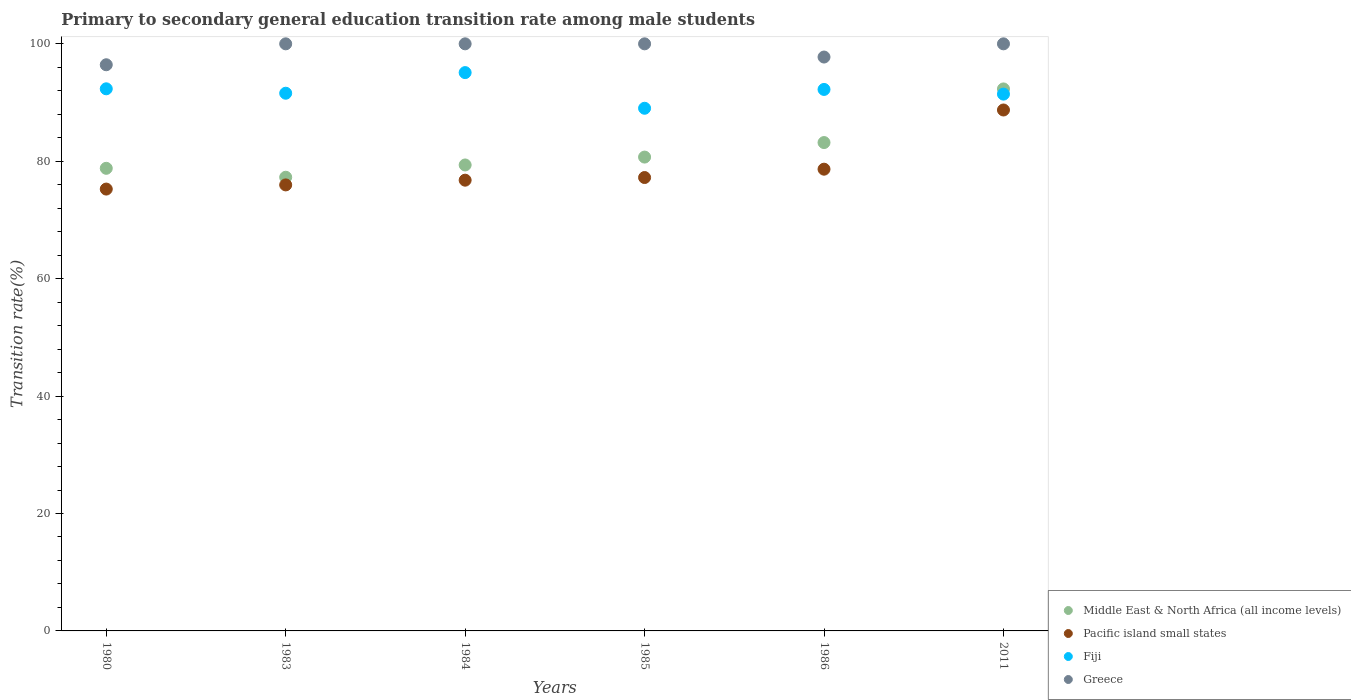How many different coloured dotlines are there?
Keep it short and to the point. 4. What is the transition rate in Greece in 1985?
Offer a very short reply. 100. Across all years, what is the maximum transition rate in Middle East & North Africa (all income levels)?
Offer a very short reply. 92.32. Across all years, what is the minimum transition rate in Greece?
Your response must be concise. 96.44. In which year was the transition rate in Middle East & North Africa (all income levels) maximum?
Ensure brevity in your answer.  2011. What is the total transition rate in Greece in the graph?
Offer a very short reply. 594.19. What is the difference between the transition rate in Pacific island small states in 1985 and that in 2011?
Keep it short and to the point. -11.5. What is the difference between the transition rate in Pacific island small states in 1986 and the transition rate in Fiji in 1980?
Ensure brevity in your answer.  -13.69. What is the average transition rate in Middle East & North Africa (all income levels) per year?
Provide a succinct answer. 81.94. In the year 1985, what is the difference between the transition rate in Pacific island small states and transition rate in Fiji?
Ensure brevity in your answer.  -11.8. In how many years, is the transition rate in Greece greater than 8 %?
Your answer should be compact. 6. What is the ratio of the transition rate in Fiji in 1980 to that in 1985?
Offer a terse response. 1.04. Is the transition rate in Middle East & North Africa (all income levels) in 1984 less than that in 1985?
Provide a succinct answer. Yes. Is the difference between the transition rate in Pacific island small states in 1986 and 2011 greater than the difference between the transition rate in Fiji in 1986 and 2011?
Provide a short and direct response. No. What is the difference between the highest and the second highest transition rate in Pacific island small states?
Your answer should be compact. 10.08. What is the difference between the highest and the lowest transition rate in Greece?
Your response must be concise. 3.56. Is it the case that in every year, the sum of the transition rate in Greece and transition rate in Fiji  is greater than the sum of transition rate in Middle East & North Africa (all income levels) and transition rate in Pacific island small states?
Make the answer very short. Yes. Does the transition rate in Pacific island small states monotonically increase over the years?
Your answer should be compact. Yes. How many dotlines are there?
Your answer should be compact. 4. What is the difference between two consecutive major ticks on the Y-axis?
Ensure brevity in your answer.  20. Does the graph contain any zero values?
Provide a succinct answer. No. Does the graph contain grids?
Offer a very short reply. No. Where does the legend appear in the graph?
Keep it short and to the point. Bottom right. How many legend labels are there?
Offer a very short reply. 4. How are the legend labels stacked?
Your answer should be very brief. Vertical. What is the title of the graph?
Give a very brief answer. Primary to secondary general education transition rate among male students. What is the label or title of the X-axis?
Offer a very short reply. Years. What is the label or title of the Y-axis?
Keep it short and to the point. Transition rate(%). What is the Transition rate(%) in Middle East & North Africa (all income levels) in 1980?
Offer a very short reply. 78.8. What is the Transition rate(%) of Pacific island small states in 1980?
Your answer should be compact. 75.26. What is the Transition rate(%) of Fiji in 1980?
Your answer should be compact. 92.34. What is the Transition rate(%) of Greece in 1980?
Your answer should be very brief. 96.44. What is the Transition rate(%) of Middle East & North Africa (all income levels) in 1983?
Offer a very short reply. 77.28. What is the Transition rate(%) in Pacific island small states in 1983?
Make the answer very short. 75.97. What is the Transition rate(%) of Fiji in 1983?
Your answer should be very brief. 91.59. What is the Transition rate(%) in Greece in 1983?
Give a very brief answer. 100. What is the Transition rate(%) in Middle East & North Africa (all income levels) in 1984?
Ensure brevity in your answer.  79.37. What is the Transition rate(%) in Pacific island small states in 1984?
Offer a very short reply. 76.78. What is the Transition rate(%) in Fiji in 1984?
Offer a very short reply. 95.1. What is the Transition rate(%) of Middle East & North Africa (all income levels) in 1985?
Offer a very short reply. 80.71. What is the Transition rate(%) of Pacific island small states in 1985?
Provide a short and direct response. 77.23. What is the Transition rate(%) of Fiji in 1985?
Make the answer very short. 89.03. What is the Transition rate(%) in Middle East & North Africa (all income levels) in 1986?
Keep it short and to the point. 83.18. What is the Transition rate(%) in Pacific island small states in 1986?
Your answer should be very brief. 78.65. What is the Transition rate(%) of Fiji in 1986?
Provide a short and direct response. 92.23. What is the Transition rate(%) of Greece in 1986?
Provide a succinct answer. 97.75. What is the Transition rate(%) of Middle East & North Africa (all income levels) in 2011?
Make the answer very short. 92.32. What is the Transition rate(%) of Pacific island small states in 2011?
Provide a short and direct response. 88.73. What is the Transition rate(%) of Fiji in 2011?
Provide a short and direct response. 91.44. What is the Transition rate(%) of Greece in 2011?
Your response must be concise. 100. Across all years, what is the maximum Transition rate(%) of Middle East & North Africa (all income levels)?
Provide a succinct answer. 92.32. Across all years, what is the maximum Transition rate(%) of Pacific island small states?
Offer a very short reply. 88.73. Across all years, what is the maximum Transition rate(%) in Fiji?
Provide a short and direct response. 95.1. Across all years, what is the maximum Transition rate(%) in Greece?
Your answer should be very brief. 100. Across all years, what is the minimum Transition rate(%) in Middle East & North Africa (all income levels)?
Offer a terse response. 77.28. Across all years, what is the minimum Transition rate(%) of Pacific island small states?
Make the answer very short. 75.26. Across all years, what is the minimum Transition rate(%) in Fiji?
Give a very brief answer. 89.03. Across all years, what is the minimum Transition rate(%) in Greece?
Your response must be concise. 96.44. What is the total Transition rate(%) in Middle East & North Africa (all income levels) in the graph?
Your answer should be very brief. 491.66. What is the total Transition rate(%) in Pacific island small states in the graph?
Make the answer very short. 472.62. What is the total Transition rate(%) of Fiji in the graph?
Ensure brevity in your answer.  551.72. What is the total Transition rate(%) in Greece in the graph?
Your response must be concise. 594.19. What is the difference between the Transition rate(%) of Middle East & North Africa (all income levels) in 1980 and that in 1983?
Offer a very short reply. 1.52. What is the difference between the Transition rate(%) in Pacific island small states in 1980 and that in 1983?
Make the answer very short. -0.71. What is the difference between the Transition rate(%) in Fiji in 1980 and that in 1983?
Provide a succinct answer. 0.75. What is the difference between the Transition rate(%) in Greece in 1980 and that in 1983?
Keep it short and to the point. -3.56. What is the difference between the Transition rate(%) in Middle East & North Africa (all income levels) in 1980 and that in 1984?
Ensure brevity in your answer.  -0.57. What is the difference between the Transition rate(%) of Pacific island small states in 1980 and that in 1984?
Make the answer very short. -1.51. What is the difference between the Transition rate(%) of Fiji in 1980 and that in 1984?
Ensure brevity in your answer.  -2.76. What is the difference between the Transition rate(%) in Greece in 1980 and that in 1984?
Provide a short and direct response. -3.56. What is the difference between the Transition rate(%) in Middle East & North Africa (all income levels) in 1980 and that in 1985?
Provide a succinct answer. -1.91. What is the difference between the Transition rate(%) in Pacific island small states in 1980 and that in 1985?
Make the answer very short. -1.97. What is the difference between the Transition rate(%) in Fiji in 1980 and that in 1985?
Give a very brief answer. 3.31. What is the difference between the Transition rate(%) of Greece in 1980 and that in 1985?
Offer a very short reply. -3.56. What is the difference between the Transition rate(%) of Middle East & North Africa (all income levels) in 1980 and that in 1986?
Your response must be concise. -4.39. What is the difference between the Transition rate(%) of Pacific island small states in 1980 and that in 1986?
Your answer should be compact. -3.39. What is the difference between the Transition rate(%) in Fiji in 1980 and that in 1986?
Your answer should be compact. 0.11. What is the difference between the Transition rate(%) in Greece in 1980 and that in 1986?
Your answer should be very brief. -1.32. What is the difference between the Transition rate(%) in Middle East & North Africa (all income levels) in 1980 and that in 2011?
Offer a very short reply. -13.52. What is the difference between the Transition rate(%) in Pacific island small states in 1980 and that in 2011?
Provide a succinct answer. -13.47. What is the difference between the Transition rate(%) in Fiji in 1980 and that in 2011?
Your answer should be very brief. 0.9. What is the difference between the Transition rate(%) of Greece in 1980 and that in 2011?
Your answer should be compact. -3.56. What is the difference between the Transition rate(%) of Middle East & North Africa (all income levels) in 1983 and that in 1984?
Give a very brief answer. -2.09. What is the difference between the Transition rate(%) in Pacific island small states in 1983 and that in 1984?
Your answer should be compact. -0.81. What is the difference between the Transition rate(%) of Fiji in 1983 and that in 1984?
Ensure brevity in your answer.  -3.51. What is the difference between the Transition rate(%) in Middle East & North Africa (all income levels) in 1983 and that in 1985?
Provide a short and direct response. -3.43. What is the difference between the Transition rate(%) of Pacific island small states in 1983 and that in 1985?
Ensure brevity in your answer.  -1.26. What is the difference between the Transition rate(%) of Fiji in 1983 and that in 1985?
Offer a very short reply. 2.56. What is the difference between the Transition rate(%) of Greece in 1983 and that in 1985?
Your response must be concise. 0. What is the difference between the Transition rate(%) of Middle East & North Africa (all income levels) in 1983 and that in 1986?
Offer a very short reply. -5.91. What is the difference between the Transition rate(%) in Pacific island small states in 1983 and that in 1986?
Offer a very short reply. -2.68. What is the difference between the Transition rate(%) in Fiji in 1983 and that in 1986?
Make the answer very short. -0.65. What is the difference between the Transition rate(%) of Greece in 1983 and that in 1986?
Make the answer very short. 2.25. What is the difference between the Transition rate(%) in Middle East & North Africa (all income levels) in 1983 and that in 2011?
Offer a terse response. -15.04. What is the difference between the Transition rate(%) in Pacific island small states in 1983 and that in 2011?
Ensure brevity in your answer.  -12.76. What is the difference between the Transition rate(%) in Fiji in 1983 and that in 2011?
Offer a very short reply. 0.15. What is the difference between the Transition rate(%) of Middle East & North Africa (all income levels) in 1984 and that in 1985?
Keep it short and to the point. -1.34. What is the difference between the Transition rate(%) in Pacific island small states in 1984 and that in 1985?
Offer a very short reply. -0.45. What is the difference between the Transition rate(%) of Fiji in 1984 and that in 1985?
Your response must be concise. 6.07. What is the difference between the Transition rate(%) in Middle East & North Africa (all income levels) in 1984 and that in 1986?
Your answer should be very brief. -3.82. What is the difference between the Transition rate(%) in Pacific island small states in 1984 and that in 1986?
Give a very brief answer. -1.87. What is the difference between the Transition rate(%) of Fiji in 1984 and that in 1986?
Keep it short and to the point. 2.87. What is the difference between the Transition rate(%) in Greece in 1984 and that in 1986?
Give a very brief answer. 2.25. What is the difference between the Transition rate(%) of Middle East & North Africa (all income levels) in 1984 and that in 2011?
Provide a succinct answer. -12.95. What is the difference between the Transition rate(%) of Pacific island small states in 1984 and that in 2011?
Provide a succinct answer. -11.96. What is the difference between the Transition rate(%) in Fiji in 1984 and that in 2011?
Keep it short and to the point. 3.66. What is the difference between the Transition rate(%) of Greece in 1984 and that in 2011?
Provide a succinct answer. 0. What is the difference between the Transition rate(%) in Middle East & North Africa (all income levels) in 1985 and that in 1986?
Ensure brevity in your answer.  -2.47. What is the difference between the Transition rate(%) of Pacific island small states in 1985 and that in 1986?
Keep it short and to the point. -1.42. What is the difference between the Transition rate(%) of Fiji in 1985 and that in 1986?
Provide a short and direct response. -3.21. What is the difference between the Transition rate(%) in Greece in 1985 and that in 1986?
Give a very brief answer. 2.25. What is the difference between the Transition rate(%) of Middle East & North Africa (all income levels) in 1985 and that in 2011?
Your answer should be compact. -11.61. What is the difference between the Transition rate(%) of Pacific island small states in 1985 and that in 2011?
Offer a very short reply. -11.5. What is the difference between the Transition rate(%) of Fiji in 1985 and that in 2011?
Offer a terse response. -2.41. What is the difference between the Transition rate(%) in Middle East & North Africa (all income levels) in 1986 and that in 2011?
Keep it short and to the point. -9.14. What is the difference between the Transition rate(%) of Pacific island small states in 1986 and that in 2011?
Ensure brevity in your answer.  -10.08. What is the difference between the Transition rate(%) of Fiji in 1986 and that in 2011?
Your answer should be very brief. 0.8. What is the difference between the Transition rate(%) of Greece in 1986 and that in 2011?
Give a very brief answer. -2.25. What is the difference between the Transition rate(%) of Middle East & North Africa (all income levels) in 1980 and the Transition rate(%) of Pacific island small states in 1983?
Offer a very short reply. 2.83. What is the difference between the Transition rate(%) of Middle East & North Africa (all income levels) in 1980 and the Transition rate(%) of Fiji in 1983?
Offer a terse response. -12.79. What is the difference between the Transition rate(%) of Middle East & North Africa (all income levels) in 1980 and the Transition rate(%) of Greece in 1983?
Your answer should be very brief. -21.2. What is the difference between the Transition rate(%) in Pacific island small states in 1980 and the Transition rate(%) in Fiji in 1983?
Ensure brevity in your answer.  -16.33. What is the difference between the Transition rate(%) of Pacific island small states in 1980 and the Transition rate(%) of Greece in 1983?
Your answer should be compact. -24.74. What is the difference between the Transition rate(%) in Fiji in 1980 and the Transition rate(%) in Greece in 1983?
Keep it short and to the point. -7.66. What is the difference between the Transition rate(%) in Middle East & North Africa (all income levels) in 1980 and the Transition rate(%) in Pacific island small states in 1984?
Make the answer very short. 2.02. What is the difference between the Transition rate(%) of Middle East & North Africa (all income levels) in 1980 and the Transition rate(%) of Fiji in 1984?
Offer a very short reply. -16.3. What is the difference between the Transition rate(%) of Middle East & North Africa (all income levels) in 1980 and the Transition rate(%) of Greece in 1984?
Make the answer very short. -21.2. What is the difference between the Transition rate(%) of Pacific island small states in 1980 and the Transition rate(%) of Fiji in 1984?
Your answer should be very brief. -19.84. What is the difference between the Transition rate(%) in Pacific island small states in 1980 and the Transition rate(%) in Greece in 1984?
Offer a very short reply. -24.74. What is the difference between the Transition rate(%) of Fiji in 1980 and the Transition rate(%) of Greece in 1984?
Your response must be concise. -7.66. What is the difference between the Transition rate(%) in Middle East & North Africa (all income levels) in 1980 and the Transition rate(%) in Pacific island small states in 1985?
Provide a succinct answer. 1.57. What is the difference between the Transition rate(%) of Middle East & North Africa (all income levels) in 1980 and the Transition rate(%) of Fiji in 1985?
Your answer should be compact. -10.23. What is the difference between the Transition rate(%) of Middle East & North Africa (all income levels) in 1980 and the Transition rate(%) of Greece in 1985?
Offer a terse response. -21.2. What is the difference between the Transition rate(%) in Pacific island small states in 1980 and the Transition rate(%) in Fiji in 1985?
Give a very brief answer. -13.76. What is the difference between the Transition rate(%) of Pacific island small states in 1980 and the Transition rate(%) of Greece in 1985?
Your response must be concise. -24.74. What is the difference between the Transition rate(%) in Fiji in 1980 and the Transition rate(%) in Greece in 1985?
Ensure brevity in your answer.  -7.66. What is the difference between the Transition rate(%) in Middle East & North Africa (all income levels) in 1980 and the Transition rate(%) in Pacific island small states in 1986?
Give a very brief answer. 0.15. What is the difference between the Transition rate(%) of Middle East & North Africa (all income levels) in 1980 and the Transition rate(%) of Fiji in 1986?
Offer a terse response. -13.44. What is the difference between the Transition rate(%) in Middle East & North Africa (all income levels) in 1980 and the Transition rate(%) in Greece in 1986?
Keep it short and to the point. -18.95. What is the difference between the Transition rate(%) in Pacific island small states in 1980 and the Transition rate(%) in Fiji in 1986?
Provide a succinct answer. -16.97. What is the difference between the Transition rate(%) in Pacific island small states in 1980 and the Transition rate(%) in Greece in 1986?
Your response must be concise. -22.49. What is the difference between the Transition rate(%) of Fiji in 1980 and the Transition rate(%) of Greece in 1986?
Your answer should be compact. -5.41. What is the difference between the Transition rate(%) in Middle East & North Africa (all income levels) in 1980 and the Transition rate(%) in Pacific island small states in 2011?
Provide a succinct answer. -9.93. What is the difference between the Transition rate(%) of Middle East & North Africa (all income levels) in 1980 and the Transition rate(%) of Fiji in 2011?
Keep it short and to the point. -12.64. What is the difference between the Transition rate(%) in Middle East & North Africa (all income levels) in 1980 and the Transition rate(%) in Greece in 2011?
Offer a very short reply. -21.2. What is the difference between the Transition rate(%) of Pacific island small states in 1980 and the Transition rate(%) of Fiji in 2011?
Keep it short and to the point. -16.17. What is the difference between the Transition rate(%) in Pacific island small states in 1980 and the Transition rate(%) in Greece in 2011?
Your answer should be very brief. -24.74. What is the difference between the Transition rate(%) in Fiji in 1980 and the Transition rate(%) in Greece in 2011?
Your response must be concise. -7.66. What is the difference between the Transition rate(%) in Middle East & North Africa (all income levels) in 1983 and the Transition rate(%) in Pacific island small states in 1984?
Provide a succinct answer. 0.5. What is the difference between the Transition rate(%) in Middle East & North Africa (all income levels) in 1983 and the Transition rate(%) in Fiji in 1984?
Your answer should be very brief. -17.82. What is the difference between the Transition rate(%) of Middle East & North Africa (all income levels) in 1983 and the Transition rate(%) of Greece in 1984?
Keep it short and to the point. -22.72. What is the difference between the Transition rate(%) of Pacific island small states in 1983 and the Transition rate(%) of Fiji in 1984?
Keep it short and to the point. -19.13. What is the difference between the Transition rate(%) in Pacific island small states in 1983 and the Transition rate(%) in Greece in 1984?
Your response must be concise. -24.03. What is the difference between the Transition rate(%) in Fiji in 1983 and the Transition rate(%) in Greece in 1984?
Offer a very short reply. -8.41. What is the difference between the Transition rate(%) in Middle East & North Africa (all income levels) in 1983 and the Transition rate(%) in Pacific island small states in 1985?
Offer a very short reply. 0.05. What is the difference between the Transition rate(%) of Middle East & North Africa (all income levels) in 1983 and the Transition rate(%) of Fiji in 1985?
Provide a succinct answer. -11.75. What is the difference between the Transition rate(%) of Middle East & North Africa (all income levels) in 1983 and the Transition rate(%) of Greece in 1985?
Your response must be concise. -22.72. What is the difference between the Transition rate(%) in Pacific island small states in 1983 and the Transition rate(%) in Fiji in 1985?
Offer a very short reply. -13.06. What is the difference between the Transition rate(%) of Pacific island small states in 1983 and the Transition rate(%) of Greece in 1985?
Ensure brevity in your answer.  -24.03. What is the difference between the Transition rate(%) of Fiji in 1983 and the Transition rate(%) of Greece in 1985?
Give a very brief answer. -8.41. What is the difference between the Transition rate(%) in Middle East & North Africa (all income levels) in 1983 and the Transition rate(%) in Pacific island small states in 1986?
Ensure brevity in your answer.  -1.37. What is the difference between the Transition rate(%) in Middle East & North Africa (all income levels) in 1983 and the Transition rate(%) in Fiji in 1986?
Offer a terse response. -14.96. What is the difference between the Transition rate(%) in Middle East & North Africa (all income levels) in 1983 and the Transition rate(%) in Greece in 1986?
Your answer should be compact. -20.47. What is the difference between the Transition rate(%) in Pacific island small states in 1983 and the Transition rate(%) in Fiji in 1986?
Your response must be concise. -16.26. What is the difference between the Transition rate(%) in Pacific island small states in 1983 and the Transition rate(%) in Greece in 1986?
Keep it short and to the point. -21.78. What is the difference between the Transition rate(%) of Fiji in 1983 and the Transition rate(%) of Greece in 1986?
Your response must be concise. -6.16. What is the difference between the Transition rate(%) in Middle East & North Africa (all income levels) in 1983 and the Transition rate(%) in Pacific island small states in 2011?
Offer a terse response. -11.45. What is the difference between the Transition rate(%) of Middle East & North Africa (all income levels) in 1983 and the Transition rate(%) of Fiji in 2011?
Offer a terse response. -14.16. What is the difference between the Transition rate(%) in Middle East & North Africa (all income levels) in 1983 and the Transition rate(%) in Greece in 2011?
Keep it short and to the point. -22.72. What is the difference between the Transition rate(%) of Pacific island small states in 1983 and the Transition rate(%) of Fiji in 2011?
Your answer should be very brief. -15.46. What is the difference between the Transition rate(%) in Pacific island small states in 1983 and the Transition rate(%) in Greece in 2011?
Your response must be concise. -24.03. What is the difference between the Transition rate(%) in Fiji in 1983 and the Transition rate(%) in Greece in 2011?
Provide a short and direct response. -8.41. What is the difference between the Transition rate(%) in Middle East & North Africa (all income levels) in 1984 and the Transition rate(%) in Pacific island small states in 1985?
Offer a terse response. 2.14. What is the difference between the Transition rate(%) of Middle East & North Africa (all income levels) in 1984 and the Transition rate(%) of Fiji in 1985?
Provide a succinct answer. -9.66. What is the difference between the Transition rate(%) in Middle East & North Africa (all income levels) in 1984 and the Transition rate(%) in Greece in 1985?
Provide a short and direct response. -20.63. What is the difference between the Transition rate(%) in Pacific island small states in 1984 and the Transition rate(%) in Fiji in 1985?
Make the answer very short. -12.25. What is the difference between the Transition rate(%) in Pacific island small states in 1984 and the Transition rate(%) in Greece in 1985?
Your response must be concise. -23.22. What is the difference between the Transition rate(%) of Fiji in 1984 and the Transition rate(%) of Greece in 1985?
Ensure brevity in your answer.  -4.9. What is the difference between the Transition rate(%) in Middle East & North Africa (all income levels) in 1984 and the Transition rate(%) in Pacific island small states in 1986?
Your answer should be compact. 0.72. What is the difference between the Transition rate(%) in Middle East & North Africa (all income levels) in 1984 and the Transition rate(%) in Fiji in 1986?
Offer a terse response. -12.87. What is the difference between the Transition rate(%) of Middle East & North Africa (all income levels) in 1984 and the Transition rate(%) of Greece in 1986?
Give a very brief answer. -18.38. What is the difference between the Transition rate(%) in Pacific island small states in 1984 and the Transition rate(%) in Fiji in 1986?
Provide a succinct answer. -15.46. What is the difference between the Transition rate(%) in Pacific island small states in 1984 and the Transition rate(%) in Greece in 1986?
Provide a succinct answer. -20.98. What is the difference between the Transition rate(%) of Fiji in 1984 and the Transition rate(%) of Greece in 1986?
Offer a very short reply. -2.65. What is the difference between the Transition rate(%) of Middle East & North Africa (all income levels) in 1984 and the Transition rate(%) of Pacific island small states in 2011?
Offer a very short reply. -9.36. What is the difference between the Transition rate(%) in Middle East & North Africa (all income levels) in 1984 and the Transition rate(%) in Fiji in 2011?
Offer a very short reply. -12.07. What is the difference between the Transition rate(%) of Middle East & North Africa (all income levels) in 1984 and the Transition rate(%) of Greece in 2011?
Make the answer very short. -20.63. What is the difference between the Transition rate(%) of Pacific island small states in 1984 and the Transition rate(%) of Fiji in 2011?
Your answer should be compact. -14.66. What is the difference between the Transition rate(%) of Pacific island small states in 1984 and the Transition rate(%) of Greece in 2011?
Keep it short and to the point. -23.22. What is the difference between the Transition rate(%) in Fiji in 1984 and the Transition rate(%) in Greece in 2011?
Give a very brief answer. -4.9. What is the difference between the Transition rate(%) of Middle East & North Africa (all income levels) in 1985 and the Transition rate(%) of Pacific island small states in 1986?
Offer a very short reply. 2.06. What is the difference between the Transition rate(%) of Middle East & North Africa (all income levels) in 1985 and the Transition rate(%) of Fiji in 1986?
Offer a terse response. -11.52. What is the difference between the Transition rate(%) in Middle East & North Africa (all income levels) in 1985 and the Transition rate(%) in Greece in 1986?
Ensure brevity in your answer.  -17.04. What is the difference between the Transition rate(%) in Pacific island small states in 1985 and the Transition rate(%) in Fiji in 1986?
Give a very brief answer. -15.01. What is the difference between the Transition rate(%) in Pacific island small states in 1985 and the Transition rate(%) in Greece in 1986?
Provide a succinct answer. -20.52. What is the difference between the Transition rate(%) in Fiji in 1985 and the Transition rate(%) in Greece in 1986?
Offer a terse response. -8.72. What is the difference between the Transition rate(%) in Middle East & North Africa (all income levels) in 1985 and the Transition rate(%) in Pacific island small states in 2011?
Ensure brevity in your answer.  -8.02. What is the difference between the Transition rate(%) in Middle East & North Africa (all income levels) in 1985 and the Transition rate(%) in Fiji in 2011?
Offer a very short reply. -10.73. What is the difference between the Transition rate(%) of Middle East & North Africa (all income levels) in 1985 and the Transition rate(%) of Greece in 2011?
Provide a short and direct response. -19.29. What is the difference between the Transition rate(%) in Pacific island small states in 1985 and the Transition rate(%) in Fiji in 2011?
Give a very brief answer. -14.21. What is the difference between the Transition rate(%) of Pacific island small states in 1985 and the Transition rate(%) of Greece in 2011?
Your answer should be very brief. -22.77. What is the difference between the Transition rate(%) in Fiji in 1985 and the Transition rate(%) in Greece in 2011?
Your answer should be very brief. -10.97. What is the difference between the Transition rate(%) in Middle East & North Africa (all income levels) in 1986 and the Transition rate(%) in Pacific island small states in 2011?
Provide a short and direct response. -5.55. What is the difference between the Transition rate(%) in Middle East & North Africa (all income levels) in 1986 and the Transition rate(%) in Fiji in 2011?
Ensure brevity in your answer.  -8.25. What is the difference between the Transition rate(%) in Middle East & North Africa (all income levels) in 1986 and the Transition rate(%) in Greece in 2011?
Offer a very short reply. -16.82. What is the difference between the Transition rate(%) of Pacific island small states in 1986 and the Transition rate(%) of Fiji in 2011?
Your response must be concise. -12.79. What is the difference between the Transition rate(%) of Pacific island small states in 1986 and the Transition rate(%) of Greece in 2011?
Keep it short and to the point. -21.35. What is the difference between the Transition rate(%) in Fiji in 1986 and the Transition rate(%) in Greece in 2011?
Make the answer very short. -7.77. What is the average Transition rate(%) of Middle East & North Africa (all income levels) per year?
Your answer should be compact. 81.94. What is the average Transition rate(%) of Pacific island small states per year?
Make the answer very short. 78.77. What is the average Transition rate(%) of Fiji per year?
Provide a short and direct response. 91.95. What is the average Transition rate(%) in Greece per year?
Offer a very short reply. 99.03. In the year 1980, what is the difference between the Transition rate(%) in Middle East & North Africa (all income levels) and Transition rate(%) in Pacific island small states?
Give a very brief answer. 3.54. In the year 1980, what is the difference between the Transition rate(%) in Middle East & North Africa (all income levels) and Transition rate(%) in Fiji?
Give a very brief answer. -13.54. In the year 1980, what is the difference between the Transition rate(%) of Middle East & North Africa (all income levels) and Transition rate(%) of Greece?
Offer a terse response. -17.64. In the year 1980, what is the difference between the Transition rate(%) in Pacific island small states and Transition rate(%) in Fiji?
Keep it short and to the point. -17.08. In the year 1980, what is the difference between the Transition rate(%) in Pacific island small states and Transition rate(%) in Greece?
Give a very brief answer. -21.17. In the year 1980, what is the difference between the Transition rate(%) in Fiji and Transition rate(%) in Greece?
Offer a terse response. -4.1. In the year 1983, what is the difference between the Transition rate(%) of Middle East & North Africa (all income levels) and Transition rate(%) of Pacific island small states?
Your response must be concise. 1.31. In the year 1983, what is the difference between the Transition rate(%) of Middle East & North Africa (all income levels) and Transition rate(%) of Fiji?
Provide a succinct answer. -14.31. In the year 1983, what is the difference between the Transition rate(%) of Middle East & North Africa (all income levels) and Transition rate(%) of Greece?
Make the answer very short. -22.72. In the year 1983, what is the difference between the Transition rate(%) of Pacific island small states and Transition rate(%) of Fiji?
Your response must be concise. -15.62. In the year 1983, what is the difference between the Transition rate(%) in Pacific island small states and Transition rate(%) in Greece?
Your answer should be very brief. -24.03. In the year 1983, what is the difference between the Transition rate(%) of Fiji and Transition rate(%) of Greece?
Your answer should be very brief. -8.41. In the year 1984, what is the difference between the Transition rate(%) of Middle East & North Africa (all income levels) and Transition rate(%) of Pacific island small states?
Ensure brevity in your answer.  2.59. In the year 1984, what is the difference between the Transition rate(%) in Middle East & North Africa (all income levels) and Transition rate(%) in Fiji?
Make the answer very short. -15.73. In the year 1984, what is the difference between the Transition rate(%) in Middle East & North Africa (all income levels) and Transition rate(%) in Greece?
Keep it short and to the point. -20.63. In the year 1984, what is the difference between the Transition rate(%) of Pacific island small states and Transition rate(%) of Fiji?
Your answer should be compact. -18.32. In the year 1984, what is the difference between the Transition rate(%) in Pacific island small states and Transition rate(%) in Greece?
Your answer should be compact. -23.22. In the year 1984, what is the difference between the Transition rate(%) in Fiji and Transition rate(%) in Greece?
Give a very brief answer. -4.9. In the year 1985, what is the difference between the Transition rate(%) of Middle East & North Africa (all income levels) and Transition rate(%) of Pacific island small states?
Offer a very short reply. 3.48. In the year 1985, what is the difference between the Transition rate(%) of Middle East & North Africa (all income levels) and Transition rate(%) of Fiji?
Your response must be concise. -8.32. In the year 1985, what is the difference between the Transition rate(%) of Middle East & North Africa (all income levels) and Transition rate(%) of Greece?
Provide a short and direct response. -19.29. In the year 1985, what is the difference between the Transition rate(%) of Pacific island small states and Transition rate(%) of Fiji?
Your answer should be compact. -11.8. In the year 1985, what is the difference between the Transition rate(%) in Pacific island small states and Transition rate(%) in Greece?
Your answer should be compact. -22.77. In the year 1985, what is the difference between the Transition rate(%) of Fiji and Transition rate(%) of Greece?
Give a very brief answer. -10.97. In the year 1986, what is the difference between the Transition rate(%) in Middle East & North Africa (all income levels) and Transition rate(%) in Pacific island small states?
Keep it short and to the point. 4.53. In the year 1986, what is the difference between the Transition rate(%) in Middle East & North Africa (all income levels) and Transition rate(%) in Fiji?
Offer a terse response. -9.05. In the year 1986, what is the difference between the Transition rate(%) in Middle East & North Africa (all income levels) and Transition rate(%) in Greece?
Your response must be concise. -14.57. In the year 1986, what is the difference between the Transition rate(%) of Pacific island small states and Transition rate(%) of Fiji?
Give a very brief answer. -13.58. In the year 1986, what is the difference between the Transition rate(%) of Pacific island small states and Transition rate(%) of Greece?
Offer a terse response. -19.1. In the year 1986, what is the difference between the Transition rate(%) of Fiji and Transition rate(%) of Greece?
Keep it short and to the point. -5.52. In the year 2011, what is the difference between the Transition rate(%) of Middle East & North Africa (all income levels) and Transition rate(%) of Pacific island small states?
Provide a succinct answer. 3.59. In the year 2011, what is the difference between the Transition rate(%) of Middle East & North Africa (all income levels) and Transition rate(%) of Fiji?
Give a very brief answer. 0.88. In the year 2011, what is the difference between the Transition rate(%) in Middle East & North Africa (all income levels) and Transition rate(%) in Greece?
Your response must be concise. -7.68. In the year 2011, what is the difference between the Transition rate(%) of Pacific island small states and Transition rate(%) of Fiji?
Provide a succinct answer. -2.7. In the year 2011, what is the difference between the Transition rate(%) of Pacific island small states and Transition rate(%) of Greece?
Give a very brief answer. -11.27. In the year 2011, what is the difference between the Transition rate(%) of Fiji and Transition rate(%) of Greece?
Give a very brief answer. -8.56. What is the ratio of the Transition rate(%) in Middle East & North Africa (all income levels) in 1980 to that in 1983?
Offer a very short reply. 1.02. What is the ratio of the Transition rate(%) of Fiji in 1980 to that in 1983?
Ensure brevity in your answer.  1.01. What is the ratio of the Transition rate(%) of Greece in 1980 to that in 1983?
Keep it short and to the point. 0.96. What is the ratio of the Transition rate(%) of Middle East & North Africa (all income levels) in 1980 to that in 1984?
Make the answer very short. 0.99. What is the ratio of the Transition rate(%) in Pacific island small states in 1980 to that in 1984?
Your answer should be very brief. 0.98. What is the ratio of the Transition rate(%) in Fiji in 1980 to that in 1984?
Provide a short and direct response. 0.97. What is the ratio of the Transition rate(%) of Greece in 1980 to that in 1984?
Your response must be concise. 0.96. What is the ratio of the Transition rate(%) of Middle East & North Africa (all income levels) in 1980 to that in 1985?
Offer a terse response. 0.98. What is the ratio of the Transition rate(%) of Pacific island small states in 1980 to that in 1985?
Ensure brevity in your answer.  0.97. What is the ratio of the Transition rate(%) in Fiji in 1980 to that in 1985?
Provide a succinct answer. 1.04. What is the ratio of the Transition rate(%) in Greece in 1980 to that in 1985?
Provide a succinct answer. 0.96. What is the ratio of the Transition rate(%) in Middle East & North Africa (all income levels) in 1980 to that in 1986?
Your answer should be very brief. 0.95. What is the ratio of the Transition rate(%) in Pacific island small states in 1980 to that in 1986?
Your answer should be very brief. 0.96. What is the ratio of the Transition rate(%) in Greece in 1980 to that in 1986?
Offer a terse response. 0.99. What is the ratio of the Transition rate(%) of Middle East & North Africa (all income levels) in 1980 to that in 2011?
Your answer should be compact. 0.85. What is the ratio of the Transition rate(%) in Pacific island small states in 1980 to that in 2011?
Your response must be concise. 0.85. What is the ratio of the Transition rate(%) in Fiji in 1980 to that in 2011?
Keep it short and to the point. 1.01. What is the ratio of the Transition rate(%) of Greece in 1980 to that in 2011?
Your answer should be very brief. 0.96. What is the ratio of the Transition rate(%) in Middle East & North Africa (all income levels) in 1983 to that in 1984?
Provide a short and direct response. 0.97. What is the ratio of the Transition rate(%) in Fiji in 1983 to that in 1984?
Ensure brevity in your answer.  0.96. What is the ratio of the Transition rate(%) in Middle East & North Africa (all income levels) in 1983 to that in 1985?
Provide a short and direct response. 0.96. What is the ratio of the Transition rate(%) in Pacific island small states in 1983 to that in 1985?
Your response must be concise. 0.98. What is the ratio of the Transition rate(%) in Fiji in 1983 to that in 1985?
Keep it short and to the point. 1.03. What is the ratio of the Transition rate(%) in Greece in 1983 to that in 1985?
Provide a succinct answer. 1. What is the ratio of the Transition rate(%) in Middle East & North Africa (all income levels) in 1983 to that in 1986?
Offer a very short reply. 0.93. What is the ratio of the Transition rate(%) in Pacific island small states in 1983 to that in 1986?
Your answer should be very brief. 0.97. What is the ratio of the Transition rate(%) in Greece in 1983 to that in 1986?
Your answer should be compact. 1.02. What is the ratio of the Transition rate(%) of Middle East & North Africa (all income levels) in 1983 to that in 2011?
Offer a very short reply. 0.84. What is the ratio of the Transition rate(%) of Pacific island small states in 1983 to that in 2011?
Offer a very short reply. 0.86. What is the ratio of the Transition rate(%) of Fiji in 1983 to that in 2011?
Offer a very short reply. 1. What is the ratio of the Transition rate(%) in Middle East & North Africa (all income levels) in 1984 to that in 1985?
Your answer should be very brief. 0.98. What is the ratio of the Transition rate(%) in Fiji in 1984 to that in 1985?
Your response must be concise. 1.07. What is the ratio of the Transition rate(%) in Greece in 1984 to that in 1985?
Your response must be concise. 1. What is the ratio of the Transition rate(%) of Middle East & North Africa (all income levels) in 1984 to that in 1986?
Keep it short and to the point. 0.95. What is the ratio of the Transition rate(%) in Pacific island small states in 1984 to that in 1986?
Keep it short and to the point. 0.98. What is the ratio of the Transition rate(%) in Fiji in 1984 to that in 1986?
Keep it short and to the point. 1.03. What is the ratio of the Transition rate(%) of Greece in 1984 to that in 1986?
Offer a very short reply. 1.02. What is the ratio of the Transition rate(%) of Middle East & North Africa (all income levels) in 1984 to that in 2011?
Make the answer very short. 0.86. What is the ratio of the Transition rate(%) in Pacific island small states in 1984 to that in 2011?
Offer a very short reply. 0.87. What is the ratio of the Transition rate(%) in Fiji in 1984 to that in 2011?
Give a very brief answer. 1.04. What is the ratio of the Transition rate(%) of Middle East & North Africa (all income levels) in 1985 to that in 1986?
Offer a terse response. 0.97. What is the ratio of the Transition rate(%) in Pacific island small states in 1985 to that in 1986?
Offer a very short reply. 0.98. What is the ratio of the Transition rate(%) of Fiji in 1985 to that in 1986?
Offer a very short reply. 0.97. What is the ratio of the Transition rate(%) in Greece in 1985 to that in 1986?
Ensure brevity in your answer.  1.02. What is the ratio of the Transition rate(%) of Middle East & North Africa (all income levels) in 1985 to that in 2011?
Make the answer very short. 0.87. What is the ratio of the Transition rate(%) of Pacific island small states in 1985 to that in 2011?
Offer a terse response. 0.87. What is the ratio of the Transition rate(%) of Fiji in 1985 to that in 2011?
Offer a terse response. 0.97. What is the ratio of the Transition rate(%) in Middle East & North Africa (all income levels) in 1986 to that in 2011?
Offer a very short reply. 0.9. What is the ratio of the Transition rate(%) in Pacific island small states in 1986 to that in 2011?
Keep it short and to the point. 0.89. What is the ratio of the Transition rate(%) of Fiji in 1986 to that in 2011?
Give a very brief answer. 1.01. What is the ratio of the Transition rate(%) of Greece in 1986 to that in 2011?
Your answer should be very brief. 0.98. What is the difference between the highest and the second highest Transition rate(%) in Middle East & North Africa (all income levels)?
Provide a succinct answer. 9.14. What is the difference between the highest and the second highest Transition rate(%) of Pacific island small states?
Offer a terse response. 10.08. What is the difference between the highest and the second highest Transition rate(%) of Fiji?
Your answer should be very brief. 2.76. What is the difference between the highest and the lowest Transition rate(%) of Middle East & North Africa (all income levels)?
Offer a very short reply. 15.04. What is the difference between the highest and the lowest Transition rate(%) in Pacific island small states?
Your response must be concise. 13.47. What is the difference between the highest and the lowest Transition rate(%) in Fiji?
Keep it short and to the point. 6.07. What is the difference between the highest and the lowest Transition rate(%) of Greece?
Keep it short and to the point. 3.56. 